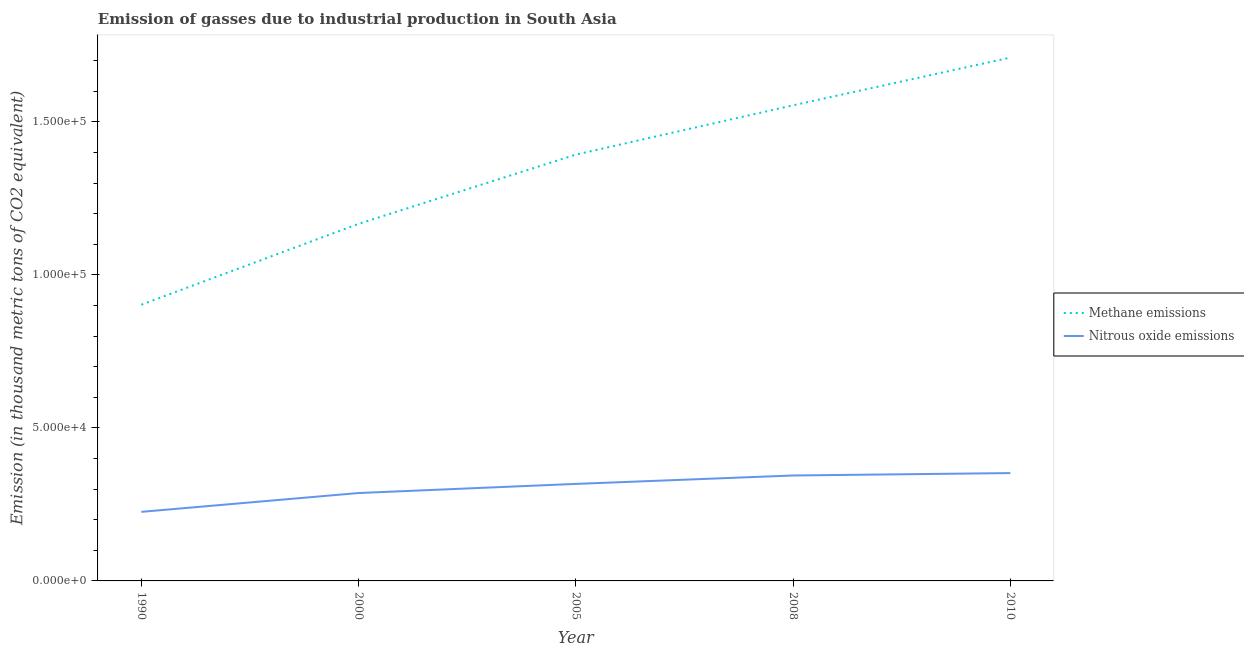Is the number of lines equal to the number of legend labels?
Your answer should be compact. Yes. What is the amount of methane emissions in 2010?
Offer a very short reply. 1.71e+05. Across all years, what is the maximum amount of nitrous oxide emissions?
Give a very brief answer. 3.52e+04. Across all years, what is the minimum amount of nitrous oxide emissions?
Offer a terse response. 2.26e+04. What is the total amount of nitrous oxide emissions in the graph?
Keep it short and to the point. 1.53e+05. What is the difference between the amount of nitrous oxide emissions in 2008 and that in 2010?
Your answer should be compact. -787.2. What is the difference between the amount of nitrous oxide emissions in 2008 and the amount of methane emissions in 2000?
Make the answer very short. -8.22e+04. What is the average amount of nitrous oxide emissions per year?
Offer a very short reply. 3.05e+04. In the year 2005, what is the difference between the amount of methane emissions and amount of nitrous oxide emissions?
Provide a short and direct response. 1.08e+05. What is the ratio of the amount of nitrous oxide emissions in 1990 to that in 2000?
Offer a terse response. 0.79. Is the amount of nitrous oxide emissions in 2000 less than that in 2010?
Offer a very short reply. Yes. Is the difference between the amount of methane emissions in 1990 and 2010 greater than the difference between the amount of nitrous oxide emissions in 1990 and 2010?
Your response must be concise. No. What is the difference between the highest and the second highest amount of methane emissions?
Ensure brevity in your answer.  1.56e+04. What is the difference between the highest and the lowest amount of nitrous oxide emissions?
Provide a succinct answer. 1.27e+04. Is the sum of the amount of nitrous oxide emissions in 2008 and 2010 greater than the maximum amount of methane emissions across all years?
Your answer should be compact. No. Does the amount of methane emissions monotonically increase over the years?
Offer a very short reply. Yes. Is the amount of methane emissions strictly greater than the amount of nitrous oxide emissions over the years?
Keep it short and to the point. Yes. Is the amount of methane emissions strictly less than the amount of nitrous oxide emissions over the years?
Your response must be concise. No. What is the difference between two consecutive major ticks on the Y-axis?
Provide a short and direct response. 5.00e+04. Are the values on the major ticks of Y-axis written in scientific E-notation?
Give a very brief answer. Yes. Does the graph contain grids?
Your answer should be compact. No. How many legend labels are there?
Keep it short and to the point. 2. What is the title of the graph?
Your answer should be compact. Emission of gasses due to industrial production in South Asia. Does "GDP" appear as one of the legend labels in the graph?
Provide a succinct answer. No. What is the label or title of the Y-axis?
Your answer should be very brief. Emission (in thousand metric tons of CO2 equivalent). What is the Emission (in thousand metric tons of CO2 equivalent) of Methane emissions in 1990?
Ensure brevity in your answer.  9.03e+04. What is the Emission (in thousand metric tons of CO2 equivalent) in Nitrous oxide emissions in 1990?
Provide a succinct answer. 2.26e+04. What is the Emission (in thousand metric tons of CO2 equivalent) in Methane emissions in 2000?
Provide a short and direct response. 1.17e+05. What is the Emission (in thousand metric tons of CO2 equivalent) of Nitrous oxide emissions in 2000?
Your answer should be compact. 2.87e+04. What is the Emission (in thousand metric tons of CO2 equivalent) of Methane emissions in 2005?
Offer a very short reply. 1.39e+05. What is the Emission (in thousand metric tons of CO2 equivalent) in Nitrous oxide emissions in 2005?
Provide a succinct answer. 3.17e+04. What is the Emission (in thousand metric tons of CO2 equivalent) of Methane emissions in 2008?
Keep it short and to the point. 1.55e+05. What is the Emission (in thousand metric tons of CO2 equivalent) of Nitrous oxide emissions in 2008?
Offer a very short reply. 3.45e+04. What is the Emission (in thousand metric tons of CO2 equivalent) in Methane emissions in 2010?
Your response must be concise. 1.71e+05. What is the Emission (in thousand metric tons of CO2 equivalent) in Nitrous oxide emissions in 2010?
Make the answer very short. 3.52e+04. Across all years, what is the maximum Emission (in thousand metric tons of CO2 equivalent) of Methane emissions?
Your answer should be compact. 1.71e+05. Across all years, what is the maximum Emission (in thousand metric tons of CO2 equivalent) of Nitrous oxide emissions?
Ensure brevity in your answer.  3.52e+04. Across all years, what is the minimum Emission (in thousand metric tons of CO2 equivalent) in Methane emissions?
Ensure brevity in your answer.  9.03e+04. Across all years, what is the minimum Emission (in thousand metric tons of CO2 equivalent) in Nitrous oxide emissions?
Offer a very short reply. 2.26e+04. What is the total Emission (in thousand metric tons of CO2 equivalent) of Methane emissions in the graph?
Offer a terse response. 6.73e+05. What is the total Emission (in thousand metric tons of CO2 equivalent) of Nitrous oxide emissions in the graph?
Give a very brief answer. 1.53e+05. What is the difference between the Emission (in thousand metric tons of CO2 equivalent) in Methane emissions in 1990 and that in 2000?
Keep it short and to the point. -2.64e+04. What is the difference between the Emission (in thousand metric tons of CO2 equivalent) in Nitrous oxide emissions in 1990 and that in 2000?
Provide a short and direct response. -6153.4. What is the difference between the Emission (in thousand metric tons of CO2 equivalent) of Methane emissions in 1990 and that in 2005?
Keep it short and to the point. -4.91e+04. What is the difference between the Emission (in thousand metric tons of CO2 equivalent) in Nitrous oxide emissions in 1990 and that in 2005?
Your answer should be compact. -9135.8. What is the difference between the Emission (in thousand metric tons of CO2 equivalent) in Methane emissions in 1990 and that in 2008?
Offer a very short reply. -6.52e+04. What is the difference between the Emission (in thousand metric tons of CO2 equivalent) of Nitrous oxide emissions in 1990 and that in 2008?
Your answer should be very brief. -1.19e+04. What is the difference between the Emission (in thousand metric tons of CO2 equivalent) in Methane emissions in 1990 and that in 2010?
Make the answer very short. -8.08e+04. What is the difference between the Emission (in thousand metric tons of CO2 equivalent) of Nitrous oxide emissions in 1990 and that in 2010?
Keep it short and to the point. -1.27e+04. What is the difference between the Emission (in thousand metric tons of CO2 equivalent) of Methane emissions in 2000 and that in 2005?
Your answer should be compact. -2.26e+04. What is the difference between the Emission (in thousand metric tons of CO2 equivalent) in Nitrous oxide emissions in 2000 and that in 2005?
Make the answer very short. -2982.4. What is the difference between the Emission (in thousand metric tons of CO2 equivalent) in Methane emissions in 2000 and that in 2008?
Your response must be concise. -3.87e+04. What is the difference between the Emission (in thousand metric tons of CO2 equivalent) in Nitrous oxide emissions in 2000 and that in 2008?
Ensure brevity in your answer.  -5731.4. What is the difference between the Emission (in thousand metric tons of CO2 equivalent) in Methane emissions in 2000 and that in 2010?
Your answer should be very brief. -5.43e+04. What is the difference between the Emission (in thousand metric tons of CO2 equivalent) in Nitrous oxide emissions in 2000 and that in 2010?
Your response must be concise. -6518.6. What is the difference between the Emission (in thousand metric tons of CO2 equivalent) in Methane emissions in 2005 and that in 2008?
Ensure brevity in your answer.  -1.61e+04. What is the difference between the Emission (in thousand metric tons of CO2 equivalent) of Nitrous oxide emissions in 2005 and that in 2008?
Make the answer very short. -2749. What is the difference between the Emission (in thousand metric tons of CO2 equivalent) in Methane emissions in 2005 and that in 2010?
Keep it short and to the point. -3.17e+04. What is the difference between the Emission (in thousand metric tons of CO2 equivalent) in Nitrous oxide emissions in 2005 and that in 2010?
Your answer should be compact. -3536.2. What is the difference between the Emission (in thousand metric tons of CO2 equivalent) in Methane emissions in 2008 and that in 2010?
Keep it short and to the point. -1.56e+04. What is the difference between the Emission (in thousand metric tons of CO2 equivalent) of Nitrous oxide emissions in 2008 and that in 2010?
Your answer should be very brief. -787.2. What is the difference between the Emission (in thousand metric tons of CO2 equivalent) in Methane emissions in 1990 and the Emission (in thousand metric tons of CO2 equivalent) in Nitrous oxide emissions in 2000?
Keep it short and to the point. 6.15e+04. What is the difference between the Emission (in thousand metric tons of CO2 equivalent) in Methane emissions in 1990 and the Emission (in thousand metric tons of CO2 equivalent) in Nitrous oxide emissions in 2005?
Provide a short and direct response. 5.86e+04. What is the difference between the Emission (in thousand metric tons of CO2 equivalent) of Methane emissions in 1990 and the Emission (in thousand metric tons of CO2 equivalent) of Nitrous oxide emissions in 2008?
Your answer should be compact. 5.58e+04. What is the difference between the Emission (in thousand metric tons of CO2 equivalent) in Methane emissions in 1990 and the Emission (in thousand metric tons of CO2 equivalent) in Nitrous oxide emissions in 2010?
Ensure brevity in your answer.  5.50e+04. What is the difference between the Emission (in thousand metric tons of CO2 equivalent) in Methane emissions in 2000 and the Emission (in thousand metric tons of CO2 equivalent) in Nitrous oxide emissions in 2005?
Offer a very short reply. 8.50e+04. What is the difference between the Emission (in thousand metric tons of CO2 equivalent) of Methane emissions in 2000 and the Emission (in thousand metric tons of CO2 equivalent) of Nitrous oxide emissions in 2008?
Your response must be concise. 8.22e+04. What is the difference between the Emission (in thousand metric tons of CO2 equivalent) of Methane emissions in 2000 and the Emission (in thousand metric tons of CO2 equivalent) of Nitrous oxide emissions in 2010?
Your answer should be compact. 8.15e+04. What is the difference between the Emission (in thousand metric tons of CO2 equivalent) of Methane emissions in 2005 and the Emission (in thousand metric tons of CO2 equivalent) of Nitrous oxide emissions in 2008?
Give a very brief answer. 1.05e+05. What is the difference between the Emission (in thousand metric tons of CO2 equivalent) of Methane emissions in 2005 and the Emission (in thousand metric tons of CO2 equivalent) of Nitrous oxide emissions in 2010?
Ensure brevity in your answer.  1.04e+05. What is the difference between the Emission (in thousand metric tons of CO2 equivalent) in Methane emissions in 2008 and the Emission (in thousand metric tons of CO2 equivalent) in Nitrous oxide emissions in 2010?
Your answer should be very brief. 1.20e+05. What is the average Emission (in thousand metric tons of CO2 equivalent) in Methane emissions per year?
Give a very brief answer. 1.35e+05. What is the average Emission (in thousand metric tons of CO2 equivalent) of Nitrous oxide emissions per year?
Make the answer very short. 3.05e+04. In the year 1990, what is the difference between the Emission (in thousand metric tons of CO2 equivalent) of Methane emissions and Emission (in thousand metric tons of CO2 equivalent) of Nitrous oxide emissions?
Your answer should be compact. 6.77e+04. In the year 2000, what is the difference between the Emission (in thousand metric tons of CO2 equivalent) of Methane emissions and Emission (in thousand metric tons of CO2 equivalent) of Nitrous oxide emissions?
Your answer should be very brief. 8.80e+04. In the year 2005, what is the difference between the Emission (in thousand metric tons of CO2 equivalent) of Methane emissions and Emission (in thousand metric tons of CO2 equivalent) of Nitrous oxide emissions?
Your answer should be compact. 1.08e+05. In the year 2008, what is the difference between the Emission (in thousand metric tons of CO2 equivalent) in Methane emissions and Emission (in thousand metric tons of CO2 equivalent) in Nitrous oxide emissions?
Provide a succinct answer. 1.21e+05. In the year 2010, what is the difference between the Emission (in thousand metric tons of CO2 equivalent) in Methane emissions and Emission (in thousand metric tons of CO2 equivalent) in Nitrous oxide emissions?
Offer a terse response. 1.36e+05. What is the ratio of the Emission (in thousand metric tons of CO2 equivalent) in Methane emissions in 1990 to that in 2000?
Give a very brief answer. 0.77. What is the ratio of the Emission (in thousand metric tons of CO2 equivalent) of Nitrous oxide emissions in 1990 to that in 2000?
Your answer should be compact. 0.79. What is the ratio of the Emission (in thousand metric tons of CO2 equivalent) in Methane emissions in 1990 to that in 2005?
Make the answer very short. 0.65. What is the ratio of the Emission (in thousand metric tons of CO2 equivalent) of Nitrous oxide emissions in 1990 to that in 2005?
Your answer should be very brief. 0.71. What is the ratio of the Emission (in thousand metric tons of CO2 equivalent) of Methane emissions in 1990 to that in 2008?
Your answer should be very brief. 0.58. What is the ratio of the Emission (in thousand metric tons of CO2 equivalent) in Nitrous oxide emissions in 1990 to that in 2008?
Your response must be concise. 0.66. What is the ratio of the Emission (in thousand metric tons of CO2 equivalent) of Methane emissions in 1990 to that in 2010?
Make the answer very short. 0.53. What is the ratio of the Emission (in thousand metric tons of CO2 equivalent) in Nitrous oxide emissions in 1990 to that in 2010?
Provide a succinct answer. 0.64. What is the ratio of the Emission (in thousand metric tons of CO2 equivalent) in Methane emissions in 2000 to that in 2005?
Keep it short and to the point. 0.84. What is the ratio of the Emission (in thousand metric tons of CO2 equivalent) in Nitrous oxide emissions in 2000 to that in 2005?
Ensure brevity in your answer.  0.91. What is the ratio of the Emission (in thousand metric tons of CO2 equivalent) in Methane emissions in 2000 to that in 2008?
Provide a succinct answer. 0.75. What is the ratio of the Emission (in thousand metric tons of CO2 equivalent) of Nitrous oxide emissions in 2000 to that in 2008?
Your response must be concise. 0.83. What is the ratio of the Emission (in thousand metric tons of CO2 equivalent) of Methane emissions in 2000 to that in 2010?
Your response must be concise. 0.68. What is the ratio of the Emission (in thousand metric tons of CO2 equivalent) of Nitrous oxide emissions in 2000 to that in 2010?
Ensure brevity in your answer.  0.81. What is the ratio of the Emission (in thousand metric tons of CO2 equivalent) in Methane emissions in 2005 to that in 2008?
Provide a succinct answer. 0.9. What is the ratio of the Emission (in thousand metric tons of CO2 equivalent) of Nitrous oxide emissions in 2005 to that in 2008?
Make the answer very short. 0.92. What is the ratio of the Emission (in thousand metric tons of CO2 equivalent) of Methane emissions in 2005 to that in 2010?
Ensure brevity in your answer.  0.81. What is the ratio of the Emission (in thousand metric tons of CO2 equivalent) of Nitrous oxide emissions in 2005 to that in 2010?
Offer a very short reply. 0.9. What is the ratio of the Emission (in thousand metric tons of CO2 equivalent) in Methane emissions in 2008 to that in 2010?
Ensure brevity in your answer.  0.91. What is the ratio of the Emission (in thousand metric tons of CO2 equivalent) of Nitrous oxide emissions in 2008 to that in 2010?
Your answer should be very brief. 0.98. What is the difference between the highest and the second highest Emission (in thousand metric tons of CO2 equivalent) in Methane emissions?
Your answer should be very brief. 1.56e+04. What is the difference between the highest and the second highest Emission (in thousand metric tons of CO2 equivalent) in Nitrous oxide emissions?
Your answer should be very brief. 787.2. What is the difference between the highest and the lowest Emission (in thousand metric tons of CO2 equivalent) of Methane emissions?
Offer a terse response. 8.08e+04. What is the difference between the highest and the lowest Emission (in thousand metric tons of CO2 equivalent) of Nitrous oxide emissions?
Your answer should be compact. 1.27e+04. 